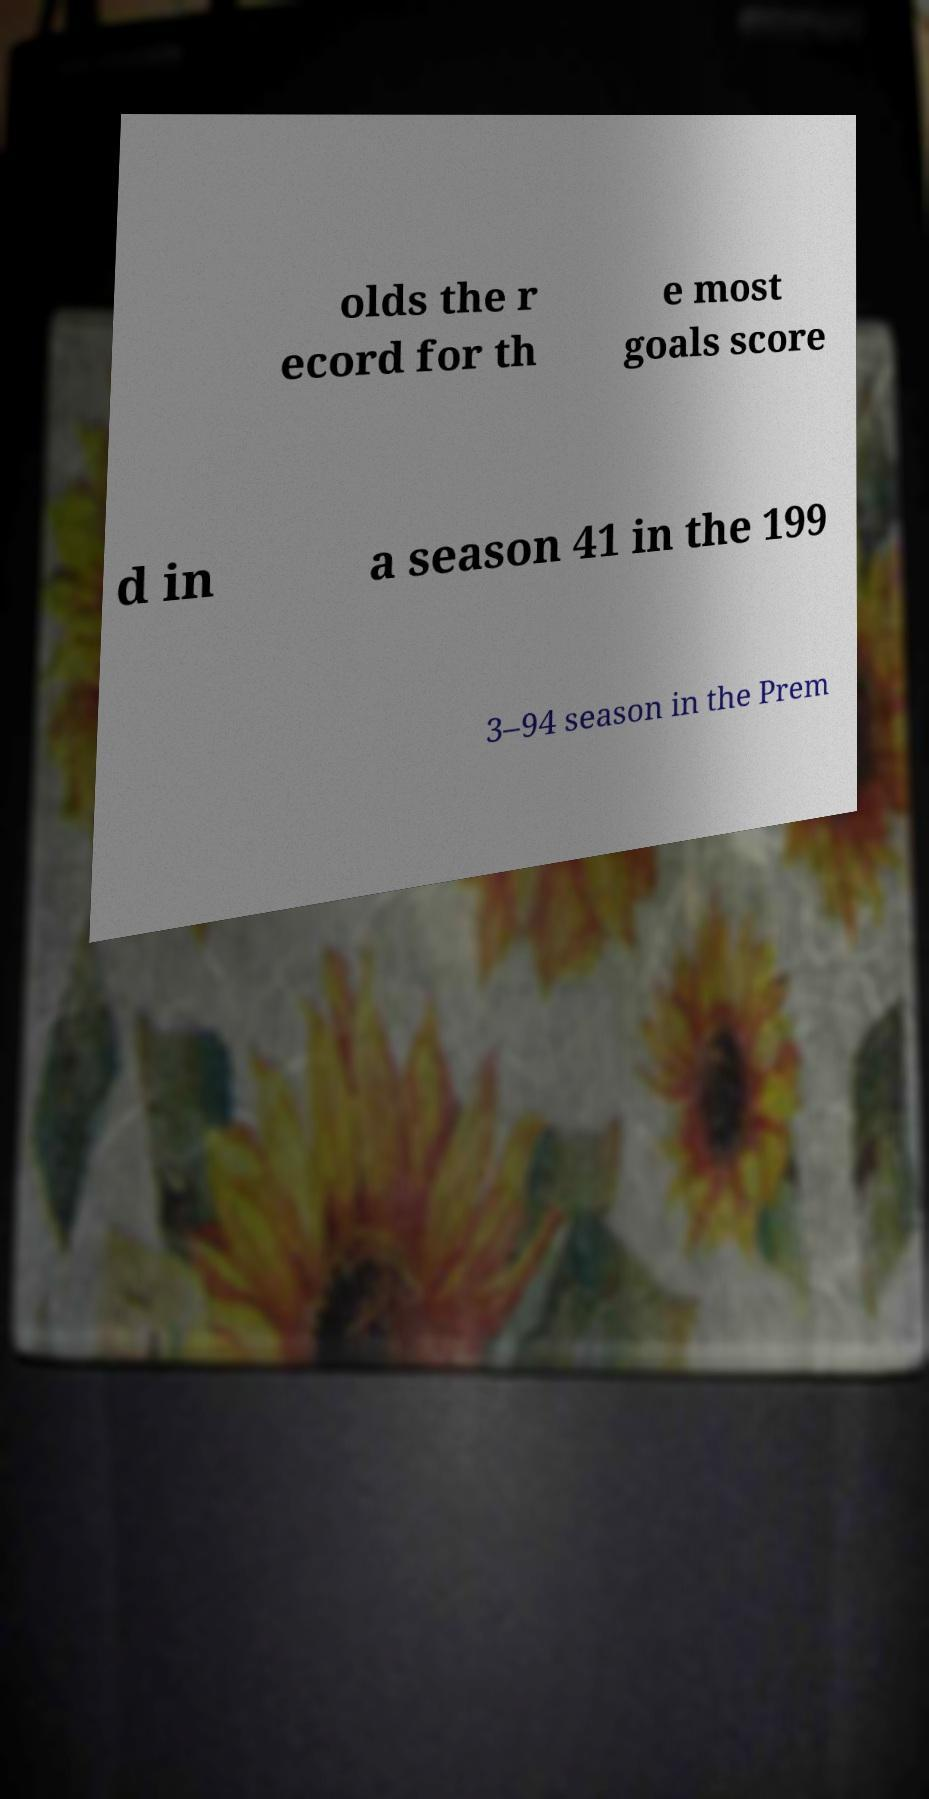There's text embedded in this image that I need extracted. Can you transcribe it verbatim? olds the r ecord for th e most goals score d in a season 41 in the 199 3–94 season in the Prem 